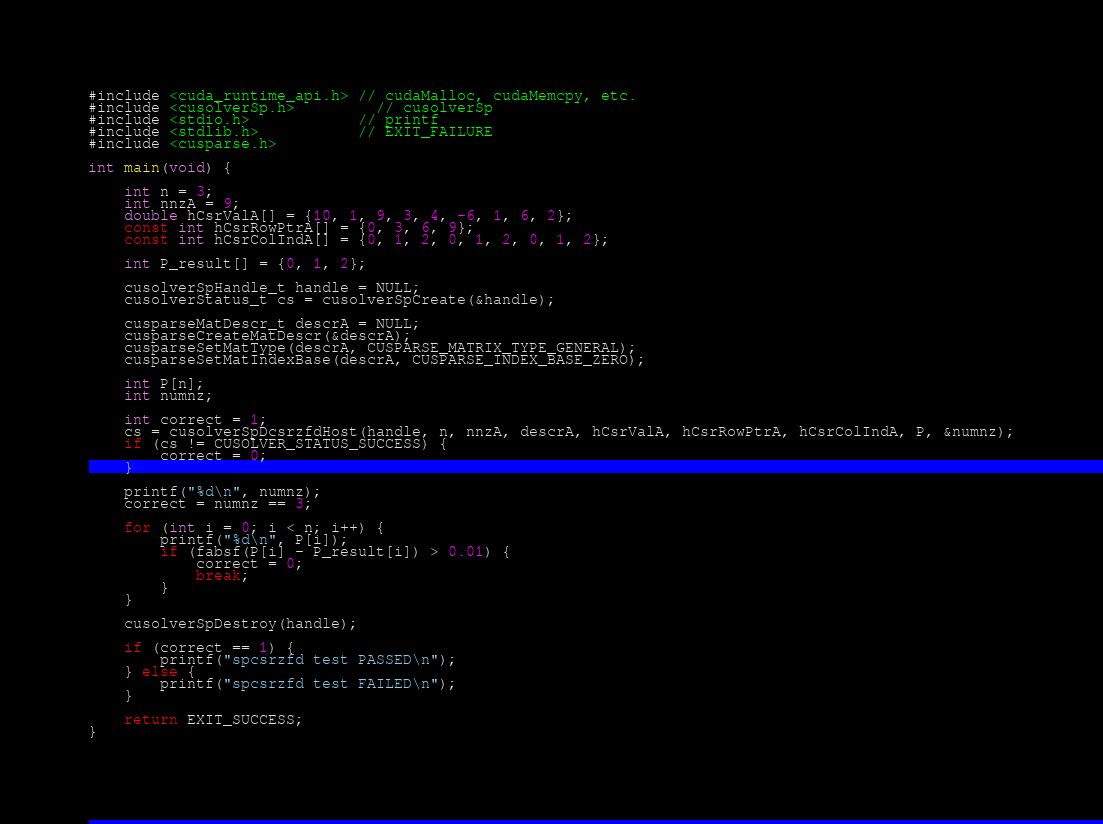<code> <loc_0><loc_0><loc_500><loc_500><_Cuda_>#include <cuda_runtime_api.h> // cudaMalloc, cudaMemcpy, etc.
#include <cusolverSp.h>         // cusolverSp
#include <stdio.h>            // printf
#include <stdlib.h>           // EXIT_FAILURE
#include <cusparse.h>

int main(void) {

    int n = 3;
    int nnzA = 9;
    double hCsrValA[] = {10, 1, 9, 3, 4, -6, 1, 6, 2};
    const int hCsrRowPtrA[] = {0, 3, 6, 9};
    const int hCsrColIndA[] = {0, 1, 2, 0, 1, 2, 0, 1, 2};

    int P_result[] = {0, 1, 2};

    cusolverSpHandle_t handle = NULL;
    cusolverStatus_t cs = cusolverSpCreate(&handle);

    cusparseMatDescr_t descrA = NULL;
    cusparseCreateMatDescr(&descrA);
    cusparseSetMatType(descrA, CUSPARSE_MATRIX_TYPE_GENERAL);
    cusparseSetMatIndexBase(descrA, CUSPARSE_INDEX_BASE_ZERO);

    int P[n];
    int numnz;

    int correct = 1;
    cs = cusolverSpDcsrzfdHost(handle, n, nnzA, descrA, hCsrValA, hCsrRowPtrA, hCsrColIndA, P, &numnz);
    if (cs != CUSOLVER_STATUS_SUCCESS) {
        correct = 0;
    }

    printf("%d\n", numnz);
    correct = numnz == 3;

    for (int i = 0; i < n; i++) {
        printf("%d\n", P[i]);
        if (fabsf(P[i] - P_result[i]) > 0.01) {
            correct = 0;
            break;
        }
    }

    cusolverSpDestroy(handle);

    if (correct == 1) {
        printf("spcsrzfd test PASSED\n");
    } else {
        printf("spcsrzfd test FAILED\n");
    }

    return EXIT_SUCCESS;
}</code> 